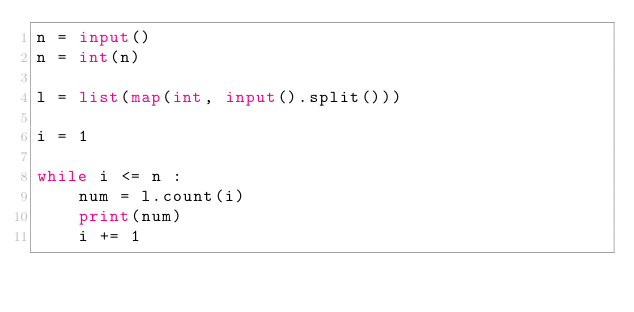<code> <loc_0><loc_0><loc_500><loc_500><_Python_>n = input()
n = int(n)

l = list(map(int, input().split()))

i = 1

while i <= n :
    num = l.count(i)
    print(num)
    i += 1</code> 